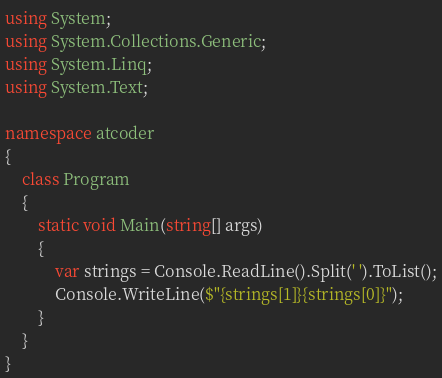Convert code to text. <code><loc_0><loc_0><loc_500><loc_500><_C#_>using System;
using System.Collections.Generic;
using System.Linq;
using System.Text;

namespace atcoder
{
    class Program
    {
        static void Main(string[] args)
        {
            var strings = Console.ReadLine().Split(' ').ToList();
            Console.WriteLine($"{strings[1]}{strings[0]}");
        }
    }
}
</code> 